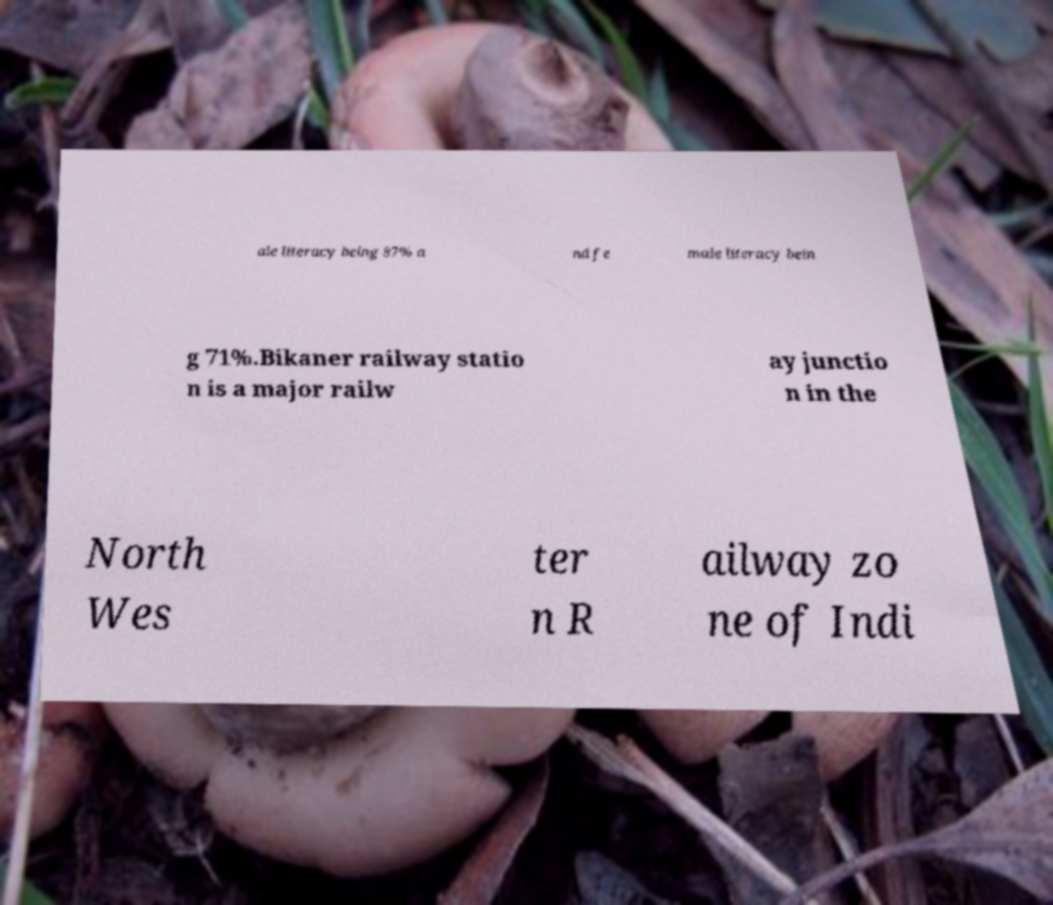Please identify and transcribe the text found in this image. ale literacy being 87% a nd fe male literacy bein g 71%.Bikaner railway statio n is a major railw ay junctio n in the North Wes ter n R ailway zo ne of Indi 